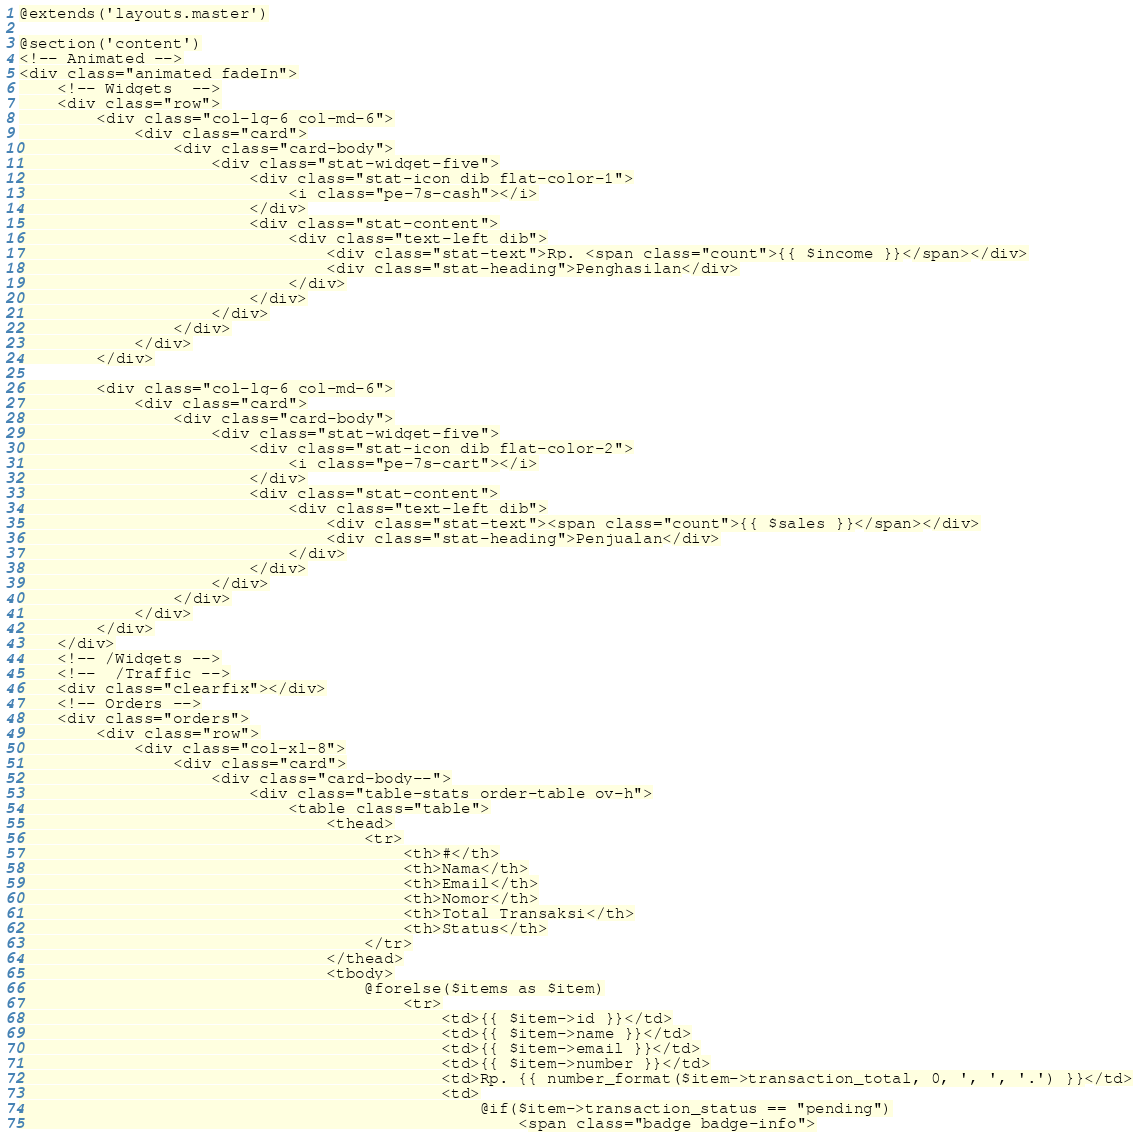<code> <loc_0><loc_0><loc_500><loc_500><_PHP_>@extends('layouts.master')

@section('content')
<!-- Animated -->
<div class="animated fadeIn">
    <!-- Widgets  -->
    <div class="row">
        <div class="col-lg-6 col-md-6">
            <div class="card">
                <div class="card-body">
                    <div class="stat-widget-five">
                        <div class="stat-icon dib flat-color-1">
                            <i class="pe-7s-cash"></i>
                        </div>
                        <div class="stat-content">
                            <div class="text-left dib">
                                <div class="stat-text">Rp. <span class="count">{{ $income }}</span></div>
                                <div class="stat-heading">Penghasilan</div>
                            </div>
                        </div>
                    </div>
                </div>
            </div>
        </div>

        <div class="col-lg-6 col-md-6">
            <div class="card">
                <div class="card-body">
                    <div class="stat-widget-five">
                        <div class="stat-icon dib flat-color-2">
                            <i class="pe-7s-cart"></i>
                        </div>
                        <div class="stat-content">
                            <div class="text-left dib">
                                <div class="stat-text"><span class="count">{{ $sales }}</span></div>
                                <div class="stat-heading">Penjualan</div>
                            </div>
                        </div>
                    </div>
                </div>
            </div>
        </div>
    </div>
    <!-- /Widgets -->
    <!--  /Traffic -->
    <div class="clearfix"></div>
    <!-- Orders -->
    <div class="orders">
        <div class="row">
            <div class="col-xl-8">
                <div class="card">
                    <div class="card-body--">
                        <div class="table-stats order-table ov-h">
                            <table class="table">
                                <thead>
                                    <tr>
                                        <th>#</th>
                                        <th>Nama</th>
                                        <th>Email</th>
                                        <th>Nomor</th>
                                        <th>Total Transaksi</th>
                                        <th>Status</th>
                                    </tr>
                                </thead>
                                <tbody>
                                    @forelse($items as $item)
                                        <tr>
                                            <td>{{ $item->id }}</td>
                                            <td>{{ $item->name }}</td>
                                            <td>{{ $item->email }}</td>
                                            <td>{{ $item->number }}</td>
                                            <td>Rp. {{ number_format($item->transaction_total, 0, ', ', '.') }}</td>
                                            <td>
                                                @if($item->transaction_status == "pending")
                                                    <span class="badge badge-info"></code> 